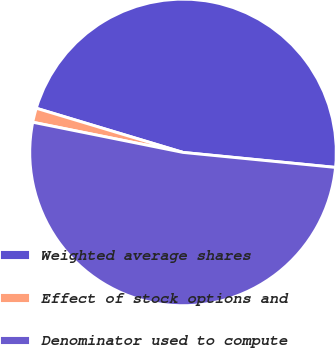Convert chart to OTSL. <chart><loc_0><loc_0><loc_500><loc_500><pie_chart><fcel>Weighted average shares<fcel>Effect of stock options and<fcel>Denominator used to compute<nl><fcel>46.91%<fcel>1.5%<fcel>51.6%<nl></chart> 